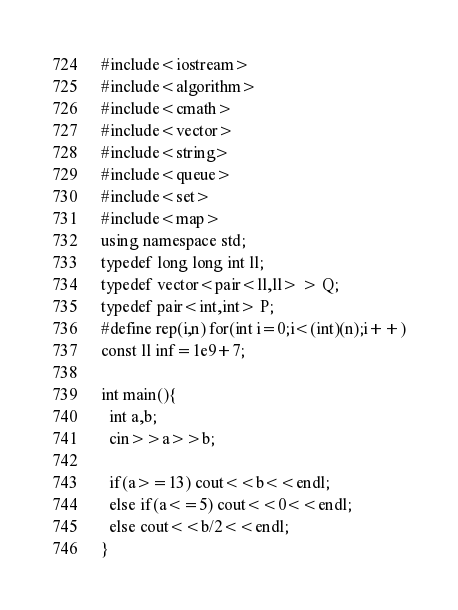<code> <loc_0><loc_0><loc_500><loc_500><_C++_>#include<iostream>
#include<algorithm>
#include<cmath>
#include<vector>
#include<string>
#include<queue>
#include<set>
#include<map>
using namespace std;
typedef long long int ll;
typedef vector<pair<ll,ll> > Q;
typedef pair<int,int> P;
#define rep(i,n) for(int i=0;i<(int)(n);i++)
const ll inf=1e9+7;

int main(){
  int a,b;
  cin>>a>>b;

  if(a>=13) cout<<b<<endl;
  else if(a<=5) cout<<0<<endl;
  else cout<<b/2<<endl;
}</code> 